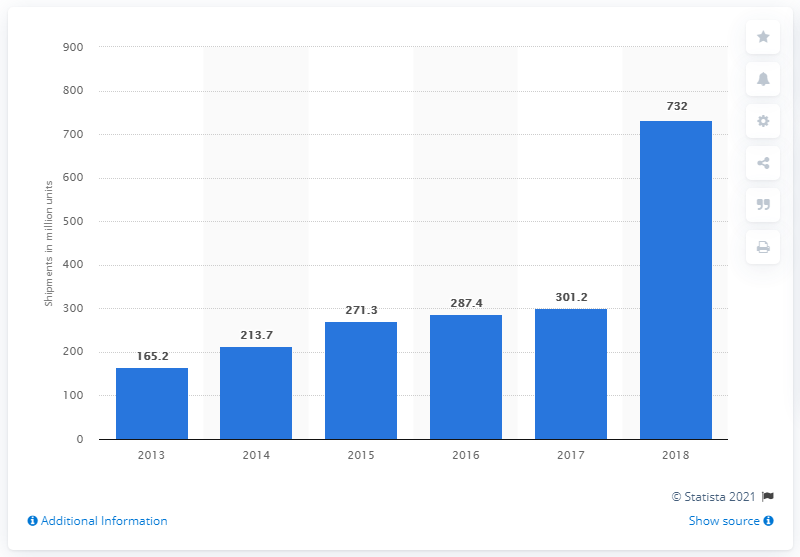List a handful of essential elements in this visual. In 2018, a significant number of smartphones were purchased in the Asia Pacific region. 